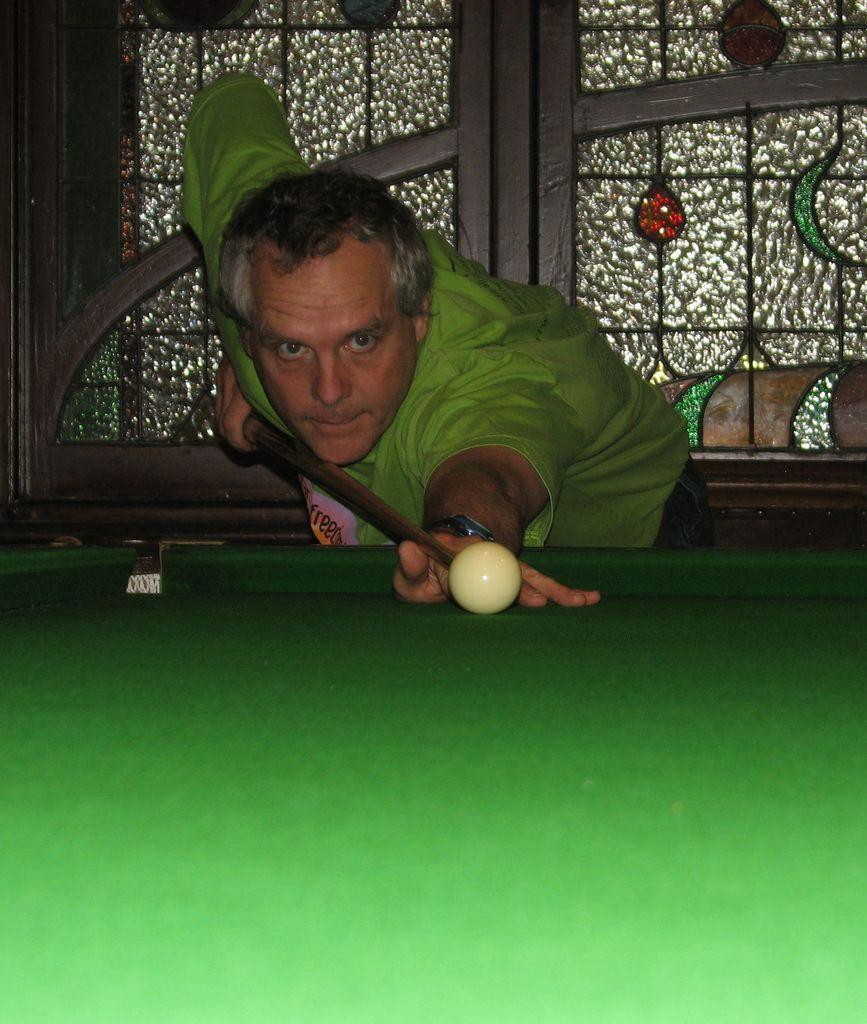What is the main subject in the foreground of the picture? There is a man in the foreground of the picture. What is the man doing in the picture? The man is playing snooker. What can be seen in the background of the picture? There is a window in the background of the picture. What type of apparatus is the man using to shake hands in the image? There is no apparatus or handshake present in the image; the man is playing snooker. What color is the man's shirt in the image? The provided facts do not mention the color of the man's shirt, so it cannot be determined from the image. 